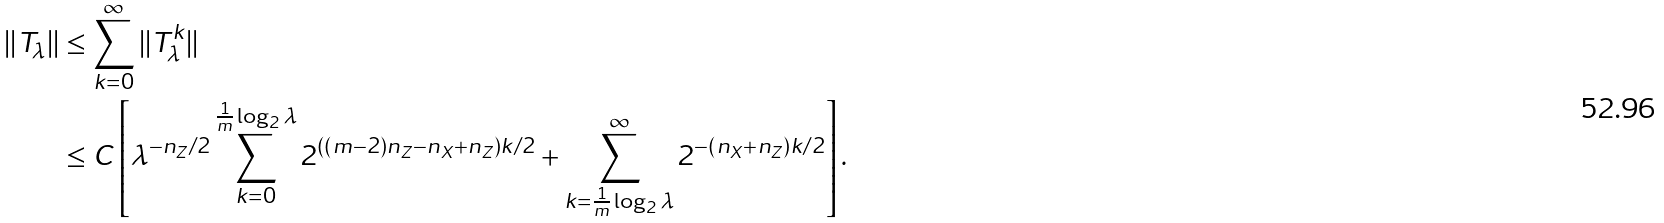<formula> <loc_0><loc_0><loc_500><loc_500>| | T _ { \lambda } | | & \leq \sum _ { k = 0 } ^ { \infty } | | T _ { \lambda } ^ { k } | | \\ & \leq C \left [ \lambda ^ { - n _ { Z } / 2 } \sum _ { k = 0 } ^ { \frac { 1 } { m } \log _ { 2 } \lambda } 2 ^ { ( ( m - 2 ) n _ { Z } - n _ { X } + n _ { Z } ) k / 2 } + \sum _ { k = \frac { 1 } { m } \log _ { 2 } \lambda } ^ { \infty } 2 ^ { - ( n _ { X } + n _ { Z } ) k / 2 } \right ] .</formula> 